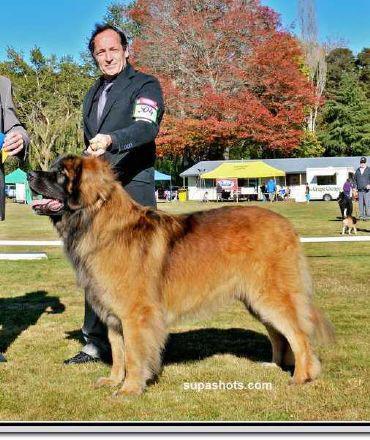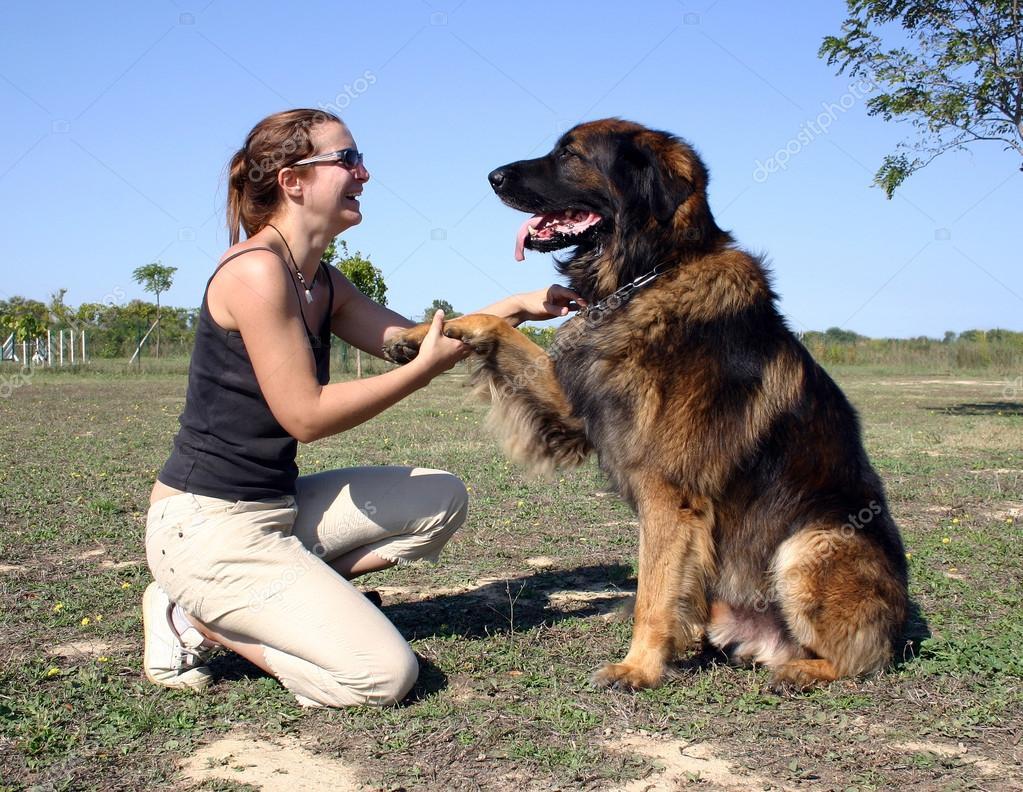The first image is the image on the left, the second image is the image on the right. Considering the images on both sides, is "A child wearing a red jacket is with a dog." valid? Answer yes or no. No. 